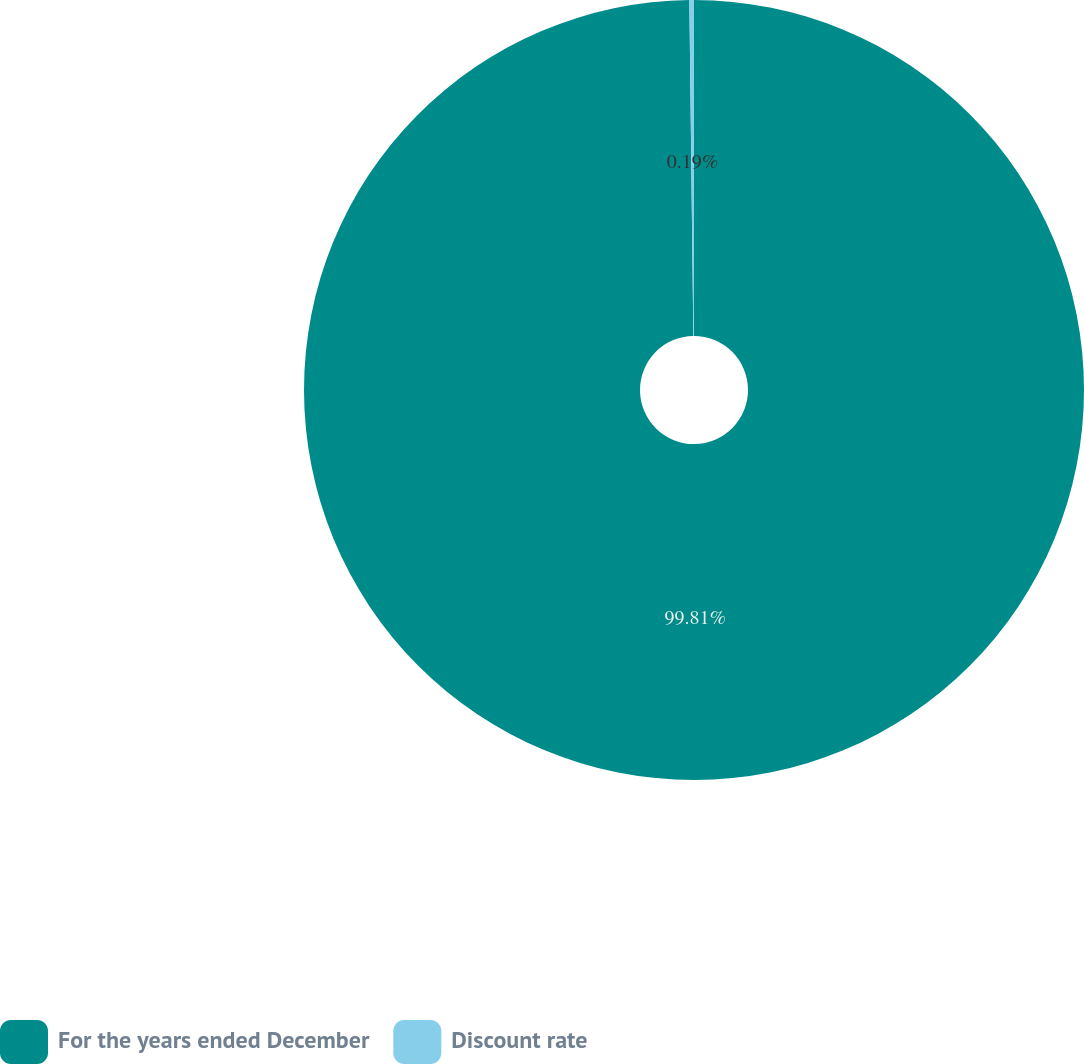<chart> <loc_0><loc_0><loc_500><loc_500><pie_chart><fcel>For the years ended December<fcel>Discount rate<nl><fcel>99.81%<fcel>0.19%<nl></chart> 